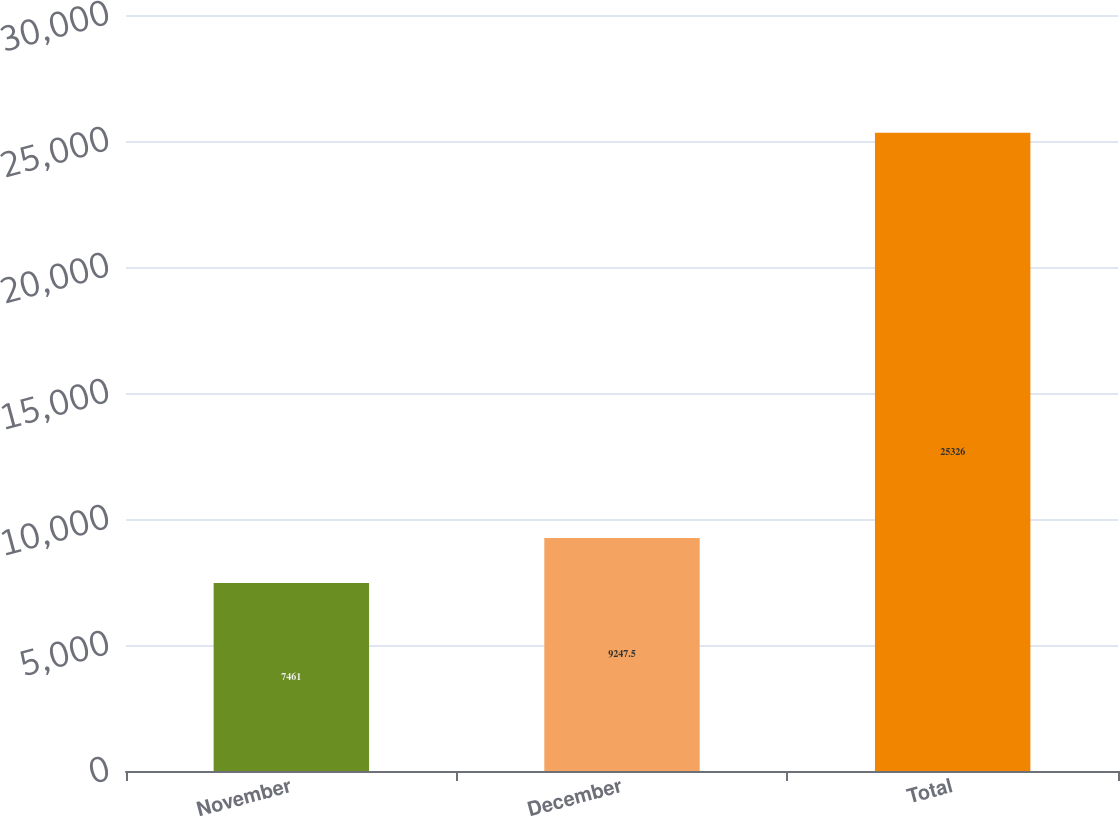Convert chart. <chart><loc_0><loc_0><loc_500><loc_500><bar_chart><fcel>November<fcel>December<fcel>Total<nl><fcel>7461<fcel>9247.5<fcel>25326<nl></chart> 